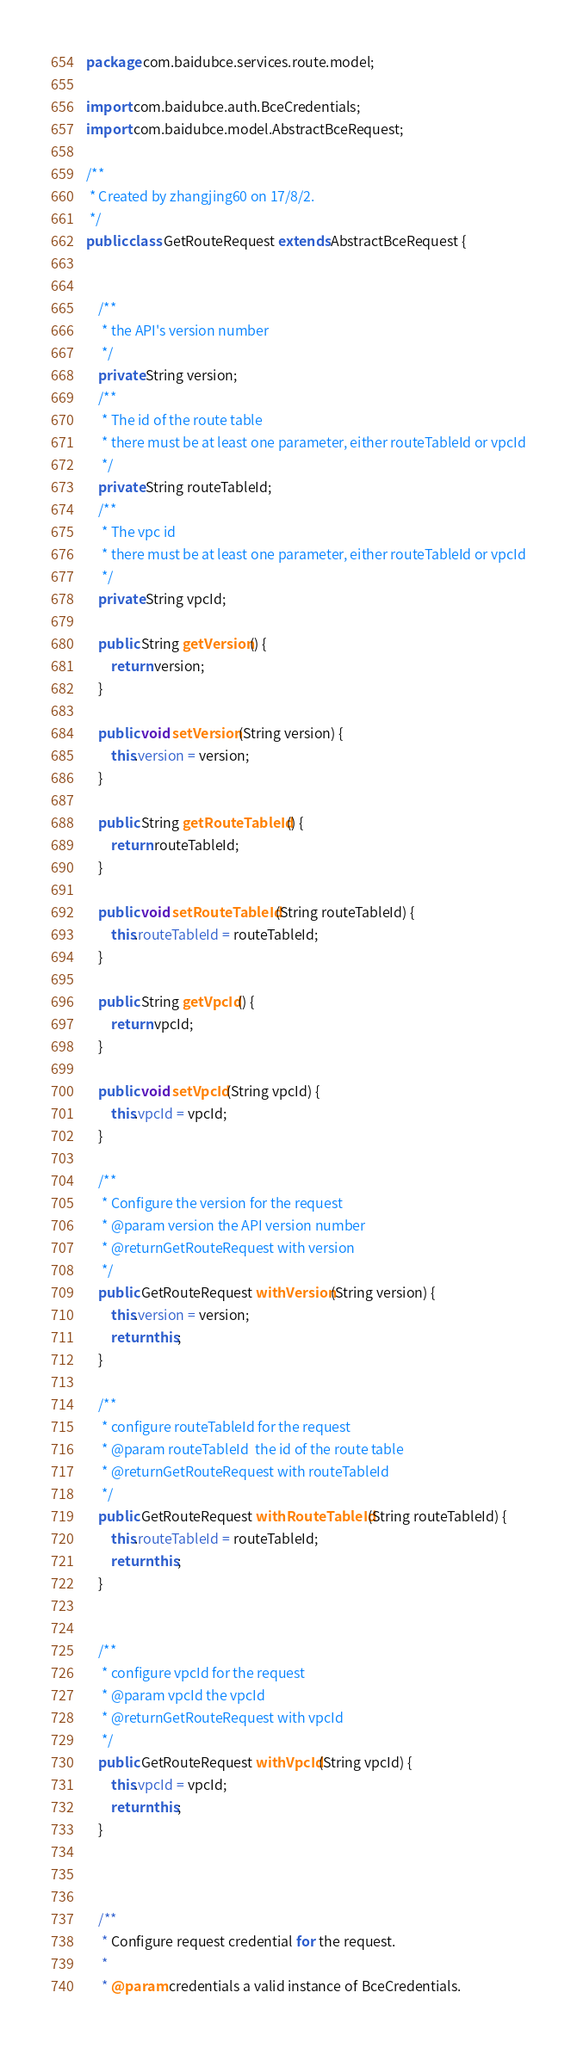<code> <loc_0><loc_0><loc_500><loc_500><_Java_>package com.baidubce.services.route.model;

import com.baidubce.auth.BceCredentials;
import com.baidubce.model.AbstractBceRequest;

/**
 * Created by zhangjing60 on 17/8/2.
 */
public class GetRouteRequest extends AbstractBceRequest {


    /**
     * the API's version number
     */
    private String version;
    /**
     * The id of the route table
     * there must be at least one parameter, either routeTableId or vpcId
     */
    private String routeTableId;
    /**
     * The vpc id
     * there must be at least one parameter, either routeTableId or vpcId
     */
    private String vpcId;

    public String getVersion() {
        return version;
    }

    public void setVersion(String version) {
        this.version = version;
    }

    public String getRouteTableId() {
        return routeTableId;
    }

    public void setRouteTableId(String routeTableId) {
        this.routeTableId = routeTableId;
    }

    public String getVpcId() {
        return vpcId;
    }

    public void setVpcId(String vpcId) {
        this.vpcId = vpcId;
    }

    /**
     * Configure the version for the request
     * @param version the API version number
     * @returnGetRouteRequest with version
     */
    public GetRouteRequest withVersion(String version) {
        this.version = version;
        return this;
    }

    /**
     * configure routeTableId for the request
     * @param routeTableId  the id of the route table
     * @returnGetRouteRequest with routeTableId
     */
    public GetRouteRequest withRouteTableId(String routeTableId) {
        this.routeTableId = routeTableId;
        return this;
    }


    /**
     * configure vpcId for the request
     * @param vpcId the vpcId
     * @returnGetRouteRequest with vpcId
     */
    public GetRouteRequest withVpcId(String vpcId) {
        this.vpcId = vpcId;
        return this;
    }



    /**
     * Configure request credential for the request.
     *
     * @param credentials a valid instance of BceCredentials.</code> 